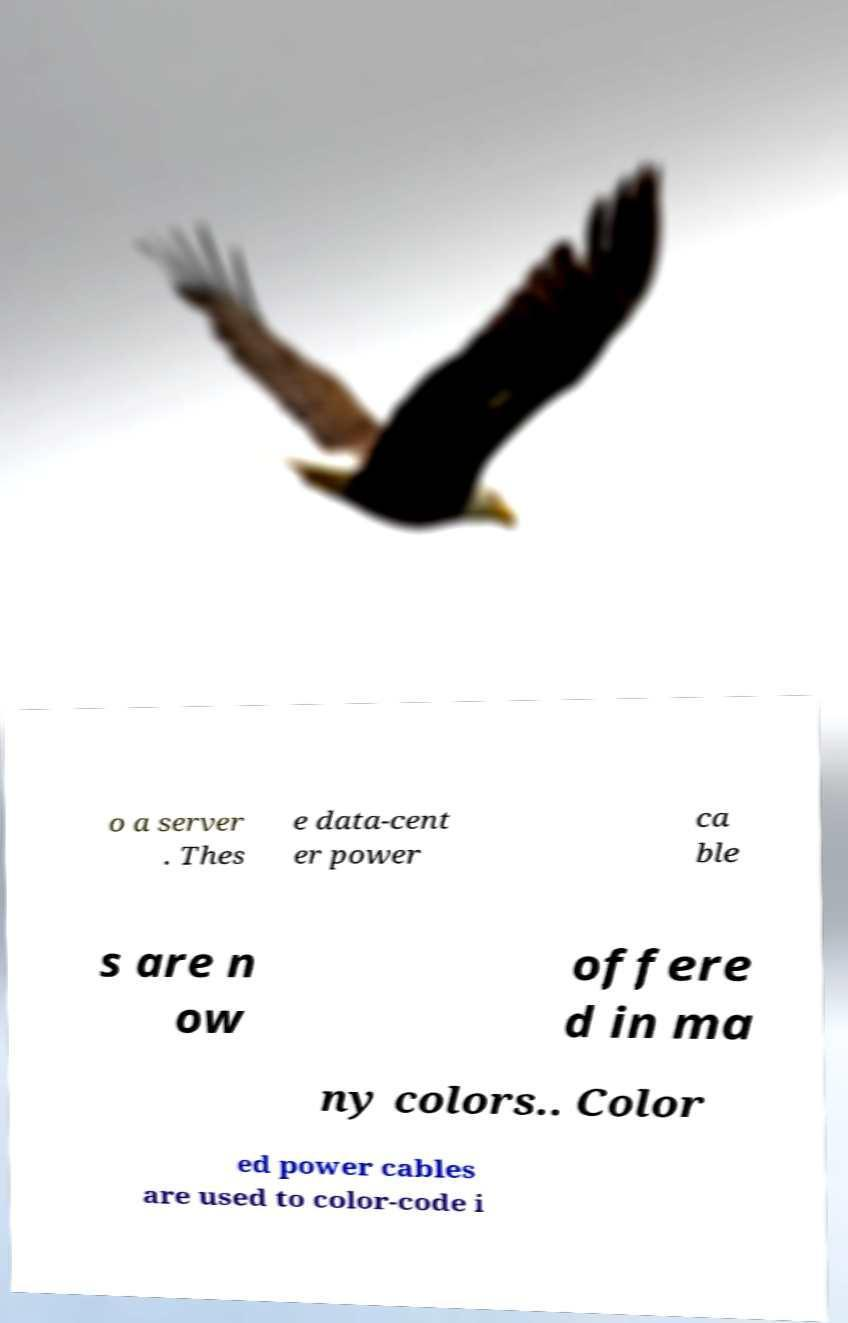Can you read and provide the text displayed in the image?This photo seems to have some interesting text. Can you extract and type it out for me? o a server . Thes e data-cent er power ca ble s are n ow offere d in ma ny colors.. Color ed power cables are used to color-code i 